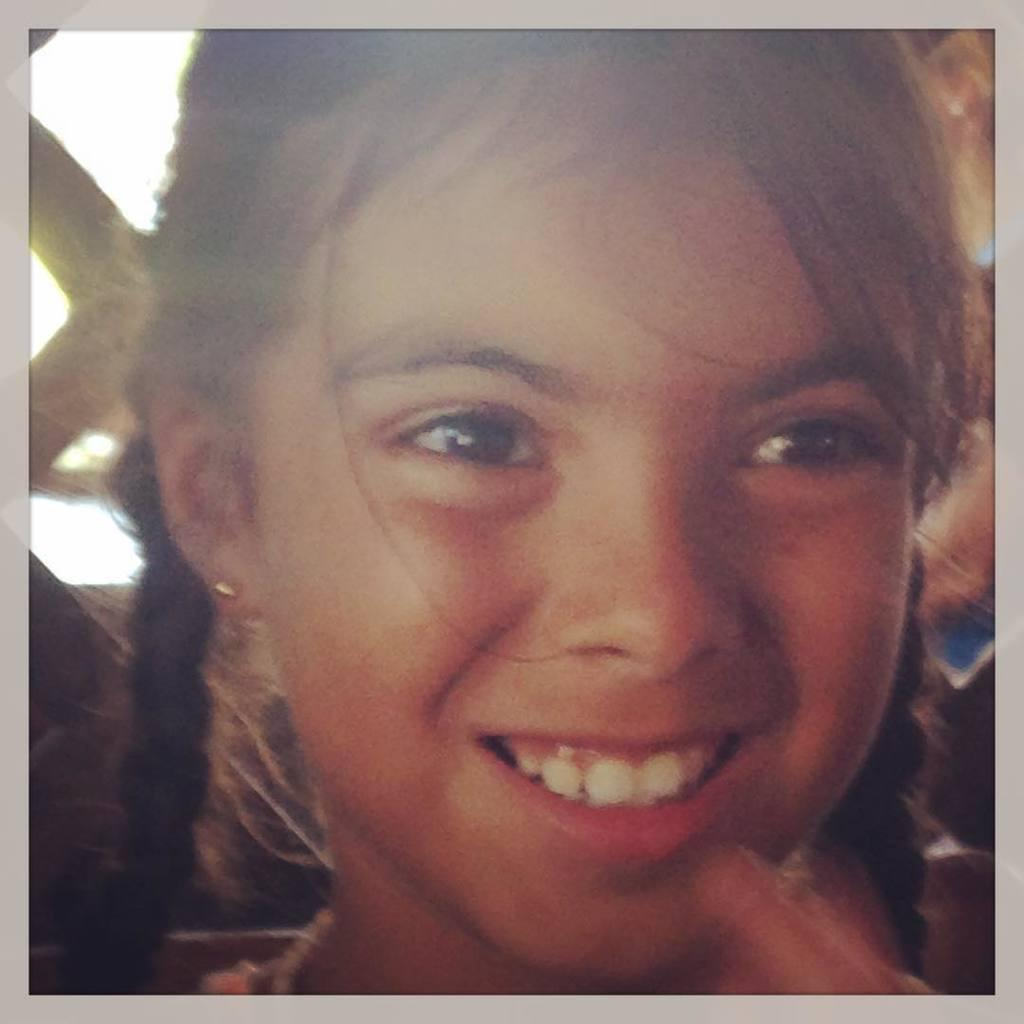Who is in the picture? There is a girl in the picture. What is the girl doing in the picture? The girl is smiling in the picture. What type of coast can be seen in the background of the image? There is no coast visible in the image; it only features a girl who is smiling. 